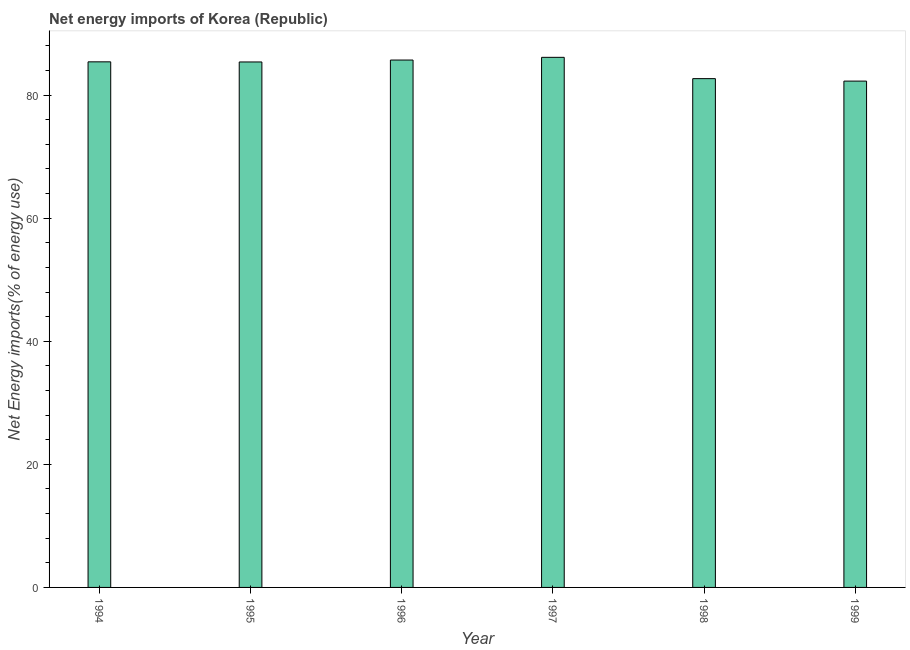Does the graph contain any zero values?
Offer a terse response. No. Does the graph contain grids?
Ensure brevity in your answer.  No. What is the title of the graph?
Ensure brevity in your answer.  Net energy imports of Korea (Republic). What is the label or title of the Y-axis?
Your answer should be compact. Net Energy imports(% of energy use). What is the energy imports in 1998?
Give a very brief answer. 82.68. Across all years, what is the maximum energy imports?
Your answer should be compact. 86.14. Across all years, what is the minimum energy imports?
Provide a succinct answer. 82.28. In which year was the energy imports maximum?
Keep it short and to the point. 1997. What is the sum of the energy imports?
Your response must be concise. 507.6. What is the difference between the energy imports in 1996 and 1998?
Provide a short and direct response. 3.02. What is the average energy imports per year?
Ensure brevity in your answer.  84.6. What is the median energy imports?
Your answer should be very brief. 85.4. In how many years, is the energy imports greater than 56 %?
Make the answer very short. 6. Do a majority of the years between 1998 and 1996 (inclusive) have energy imports greater than 20 %?
Provide a succinct answer. Yes. What is the ratio of the energy imports in 1995 to that in 1999?
Make the answer very short. 1.04. Is the energy imports in 1994 less than that in 1999?
Keep it short and to the point. No. What is the difference between the highest and the second highest energy imports?
Offer a very short reply. 0.44. Is the sum of the energy imports in 1994 and 1995 greater than the maximum energy imports across all years?
Offer a very short reply. Yes. What is the difference between the highest and the lowest energy imports?
Your response must be concise. 3.86. In how many years, is the energy imports greater than the average energy imports taken over all years?
Make the answer very short. 4. Are the values on the major ticks of Y-axis written in scientific E-notation?
Offer a very short reply. No. What is the Net Energy imports(% of energy use) of 1994?
Make the answer very short. 85.41. What is the Net Energy imports(% of energy use) in 1995?
Provide a succinct answer. 85.39. What is the Net Energy imports(% of energy use) in 1996?
Keep it short and to the point. 85.7. What is the Net Energy imports(% of energy use) of 1997?
Offer a terse response. 86.14. What is the Net Energy imports(% of energy use) of 1998?
Give a very brief answer. 82.68. What is the Net Energy imports(% of energy use) of 1999?
Offer a very short reply. 82.28. What is the difference between the Net Energy imports(% of energy use) in 1994 and 1995?
Offer a terse response. 0.02. What is the difference between the Net Energy imports(% of energy use) in 1994 and 1996?
Provide a succinct answer. -0.29. What is the difference between the Net Energy imports(% of energy use) in 1994 and 1997?
Ensure brevity in your answer.  -0.73. What is the difference between the Net Energy imports(% of energy use) in 1994 and 1998?
Offer a very short reply. 2.73. What is the difference between the Net Energy imports(% of energy use) in 1994 and 1999?
Offer a very short reply. 3.13. What is the difference between the Net Energy imports(% of energy use) in 1995 and 1996?
Your answer should be compact. -0.31. What is the difference between the Net Energy imports(% of energy use) in 1995 and 1997?
Your response must be concise. -0.75. What is the difference between the Net Energy imports(% of energy use) in 1995 and 1998?
Your answer should be compact. 2.71. What is the difference between the Net Energy imports(% of energy use) in 1995 and 1999?
Your response must be concise. 3.11. What is the difference between the Net Energy imports(% of energy use) in 1996 and 1997?
Provide a short and direct response. -0.44. What is the difference between the Net Energy imports(% of energy use) in 1996 and 1998?
Your answer should be compact. 3.02. What is the difference between the Net Energy imports(% of energy use) in 1996 and 1999?
Offer a very short reply. 3.42. What is the difference between the Net Energy imports(% of energy use) in 1997 and 1998?
Your response must be concise. 3.46. What is the difference between the Net Energy imports(% of energy use) in 1997 and 1999?
Provide a short and direct response. 3.86. What is the difference between the Net Energy imports(% of energy use) in 1998 and 1999?
Offer a very short reply. 0.4. What is the ratio of the Net Energy imports(% of energy use) in 1994 to that in 1995?
Provide a short and direct response. 1. What is the ratio of the Net Energy imports(% of energy use) in 1994 to that in 1997?
Your answer should be very brief. 0.99. What is the ratio of the Net Energy imports(% of energy use) in 1994 to that in 1998?
Make the answer very short. 1.03. What is the ratio of the Net Energy imports(% of energy use) in 1994 to that in 1999?
Provide a succinct answer. 1.04. What is the ratio of the Net Energy imports(% of energy use) in 1995 to that in 1998?
Keep it short and to the point. 1.03. What is the ratio of the Net Energy imports(% of energy use) in 1995 to that in 1999?
Keep it short and to the point. 1.04. What is the ratio of the Net Energy imports(% of energy use) in 1996 to that in 1997?
Provide a succinct answer. 0.99. What is the ratio of the Net Energy imports(% of energy use) in 1996 to that in 1999?
Offer a very short reply. 1.04. What is the ratio of the Net Energy imports(% of energy use) in 1997 to that in 1998?
Offer a terse response. 1.04. What is the ratio of the Net Energy imports(% of energy use) in 1997 to that in 1999?
Provide a short and direct response. 1.05. 